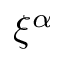<formula> <loc_0><loc_0><loc_500><loc_500>\xi ^ { \alpha }</formula> 